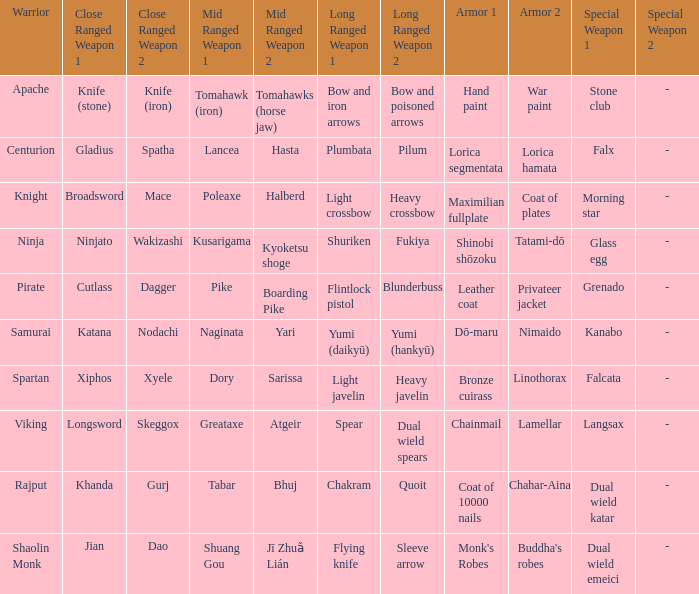If the special weapon is glass egg, what is the close ranged weapon? Ninjato , Wakizashi. 